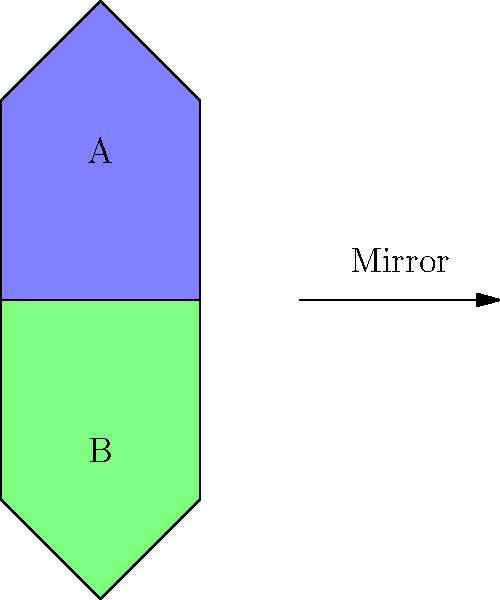As a school principal promoting visual thinking skills, you're creating a puzzle for a parent-teacher workshop. Which of the shapes shown (A or B) is the correct mirror image of the other when reflected across the horizontal line? To solve this puzzle, we need to follow these steps:

1. Identify the key features of the original shape (let's assume A is the original):
   - It has a pentagonal shape
   - The top point is slightly off-center to the right
   - The right side is vertical, while the left side is slanted

2. Understand the concept of mirror reflection:
   - In a mirror reflection, the image is reversed left-to-right
   - Distances from the mirror line remain the same
   - Angles are preserved

3. Analyze shape B:
   - It has the same pentagonal shape
   - The top point is slightly off-center to the left (opposite of A)
   - The left side is vertical, while the right side is slanted (opposite of A)

4. Compare the features:
   - The overall shape is preserved
   - The asymmetry is reversed (right becomes left, and vice versa)
   - The distances from the mirror line are maintained

5. Conclude:
   - Shape B is indeed the correct mirror image of shape A when reflected across the horizontal line

This exercise demonstrates how visual-spatial skills are important in both education and workplace scenarios, reinforcing the connection between a parent's involvement in their child's learning and their professional development.
Answer: B 